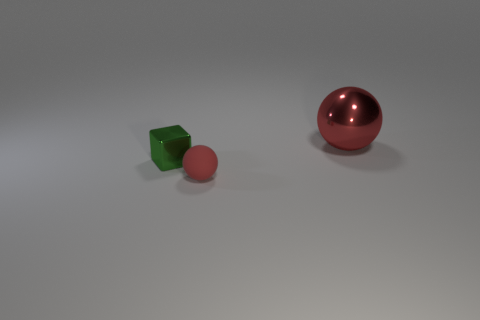Add 1 cubes. How many objects exist? 4 Subtract all balls. How many objects are left? 1 Subtract all purple spheres. Subtract all purple cylinders. How many spheres are left? 2 Subtract all purple spheres. How many gray blocks are left? 0 Subtract all large red things. Subtract all gray matte cubes. How many objects are left? 2 Add 2 shiny things. How many shiny things are left? 4 Add 2 big cyan rubber cylinders. How many big cyan rubber cylinders exist? 2 Subtract 1 green blocks. How many objects are left? 2 Subtract 2 balls. How many balls are left? 0 